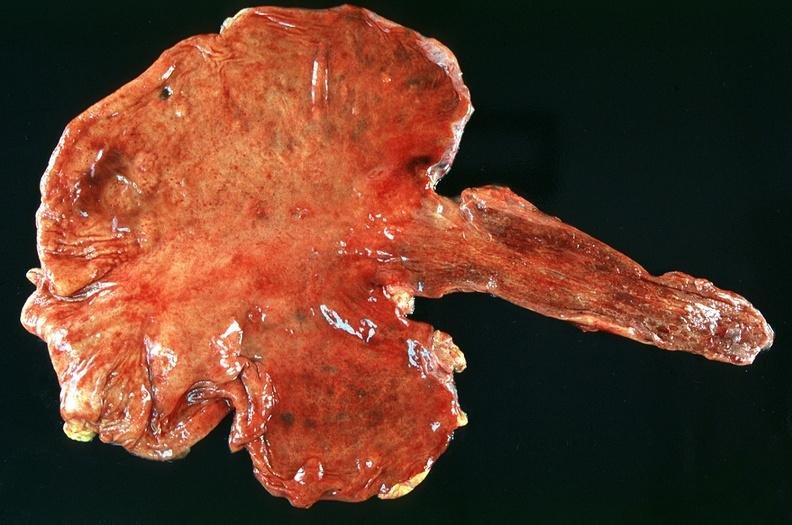what does this image show?
Answer the question using a single word or phrase. Stomach 